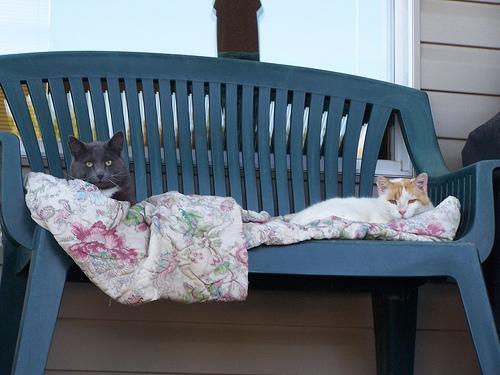How many cats are there?
Give a very brief answer. 2. How many cats are in the photo?
Give a very brief answer. 2. 